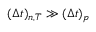Convert formula to latex. <formula><loc_0><loc_0><loc_500><loc_500>( { \Delta } t ) _ { n , T } \gg ( { \Delta } t ) _ { p }</formula> 